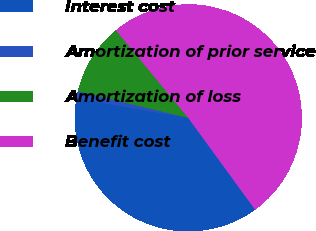Convert chart to OTSL. <chart><loc_0><loc_0><loc_500><loc_500><pie_chart><fcel>Interest cost<fcel>Amortization of prior service<fcel>Amortization of loss<fcel>Benefit cost<nl><fcel>37.75%<fcel>1.05%<fcel>10.24%<fcel>50.96%<nl></chart> 